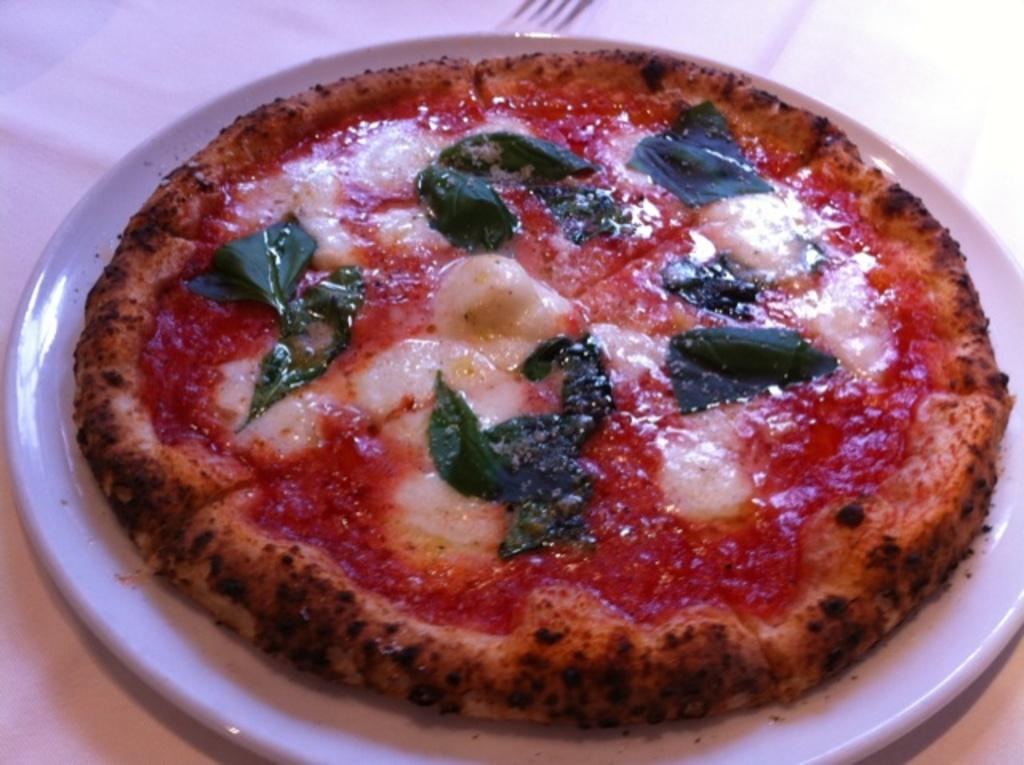What type of food is the main subject of the image? There is a pizza in the image. How is the pizza presented in the image? The pizza is on a plate. What rule is being enforced by the pizza in the image? There is no rule being enforced by the pizza in the image, as it is simply a food item. 